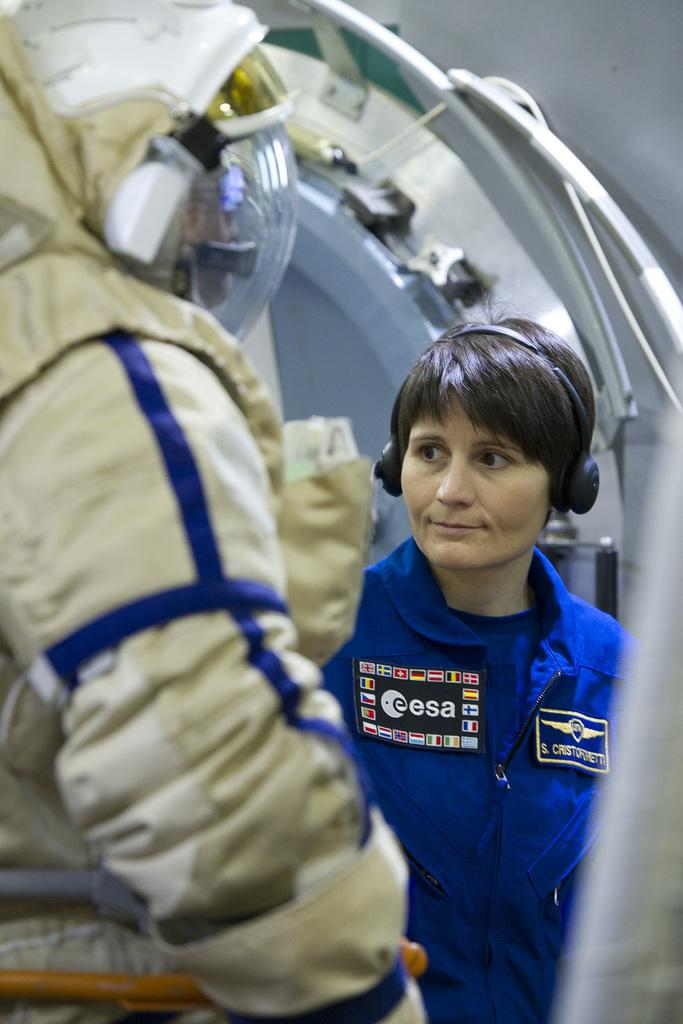Who is the main subject in the image? There is a woman in the image. What is the woman wearing? The woman is wearing a blue dress and headphones. Can you describe the person on the left side of the image? The person on the left side of the image is wearing a space suit. What might the woman be doing while wearing headphones? The woman might be listening to music or engaging in some other audio-based activity. How many babies are visible in the image? There are no babies present in the image. What is the temper of the person wearing the space suit? There is no information about the temper of the person wearing the space suit in the image. 